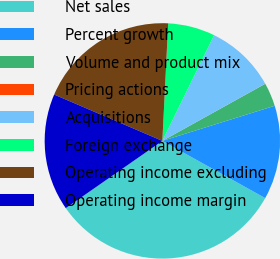Convert chart. <chart><loc_0><loc_0><loc_500><loc_500><pie_chart><fcel>Net sales<fcel>Percent growth<fcel>Volume and product mix<fcel>Pricing actions<fcel>Acquisitions<fcel>Foreign exchange<fcel>Operating income excluding<fcel>Operating income margin<nl><fcel>32.24%<fcel>12.9%<fcel>3.24%<fcel>0.01%<fcel>9.68%<fcel>6.46%<fcel>19.35%<fcel>16.12%<nl></chart> 